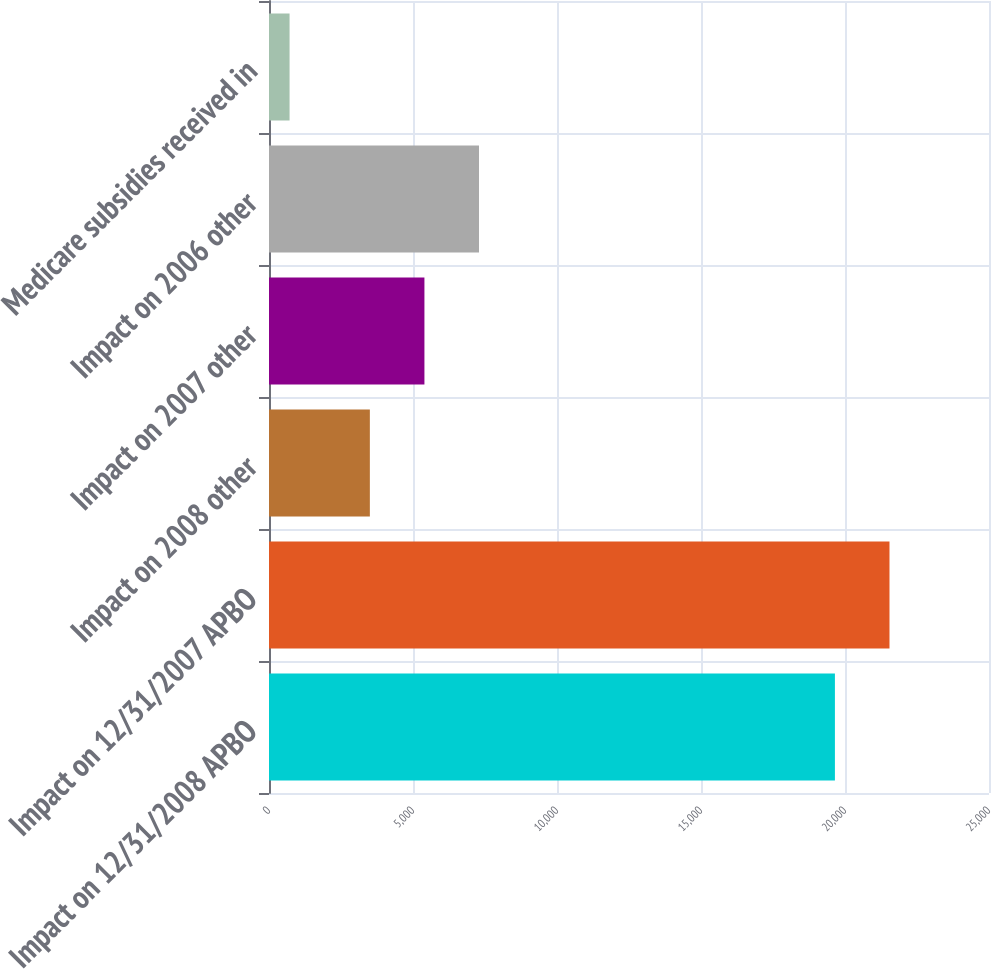<chart> <loc_0><loc_0><loc_500><loc_500><bar_chart><fcel>Impact on 12/31/2008 APBO<fcel>Impact on 12/31/2007 APBO<fcel>Impact on 2008 other<fcel>Impact on 2007 other<fcel>Impact on 2006 other<fcel>Medicare subsidies received in<nl><fcel>19650<fcel>21544.8<fcel>3502<fcel>5396.8<fcel>7291.6<fcel>714<nl></chart> 